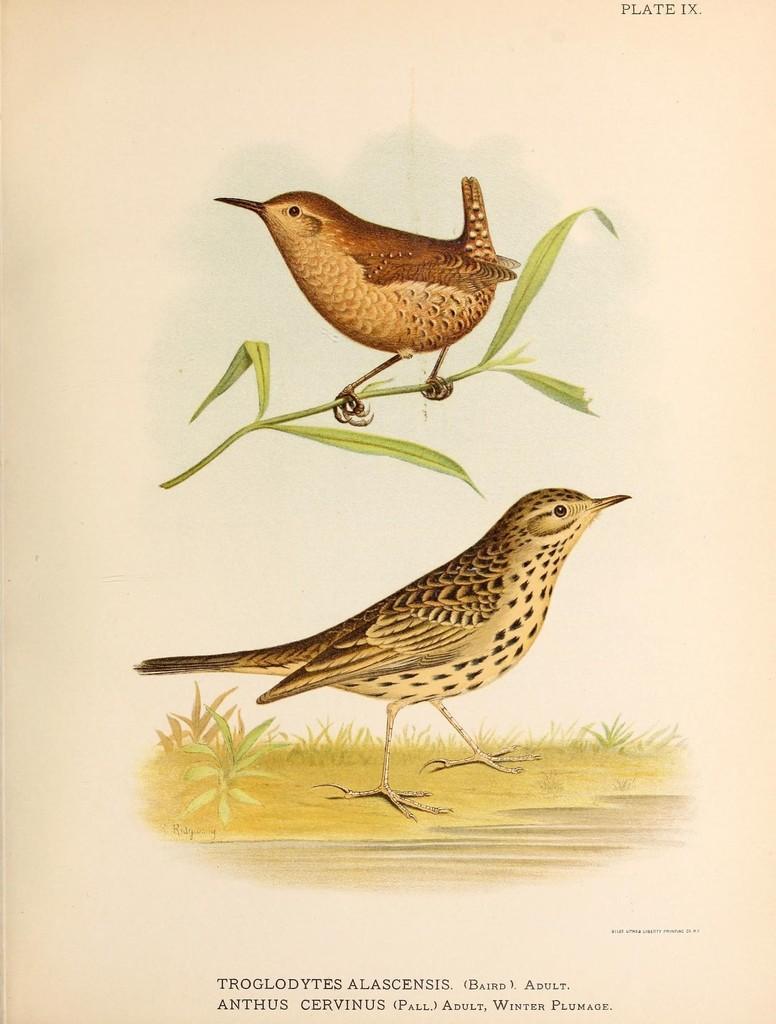How would you summarize this image in a sentence or two? In this image I can see a paper, in the paper I can see two birds. The birds are in brown and black color, I can also see stem and leaves in green color. 